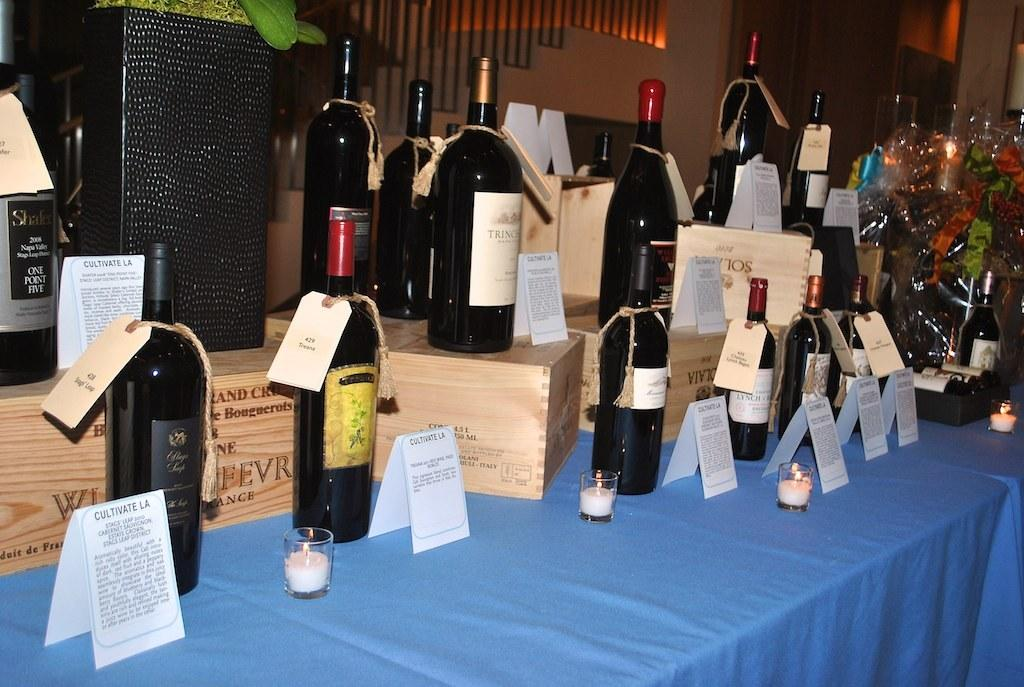<image>
Summarize the visual content of the image. A bottle of Shales One Point Five stands on a wooden box in the back 